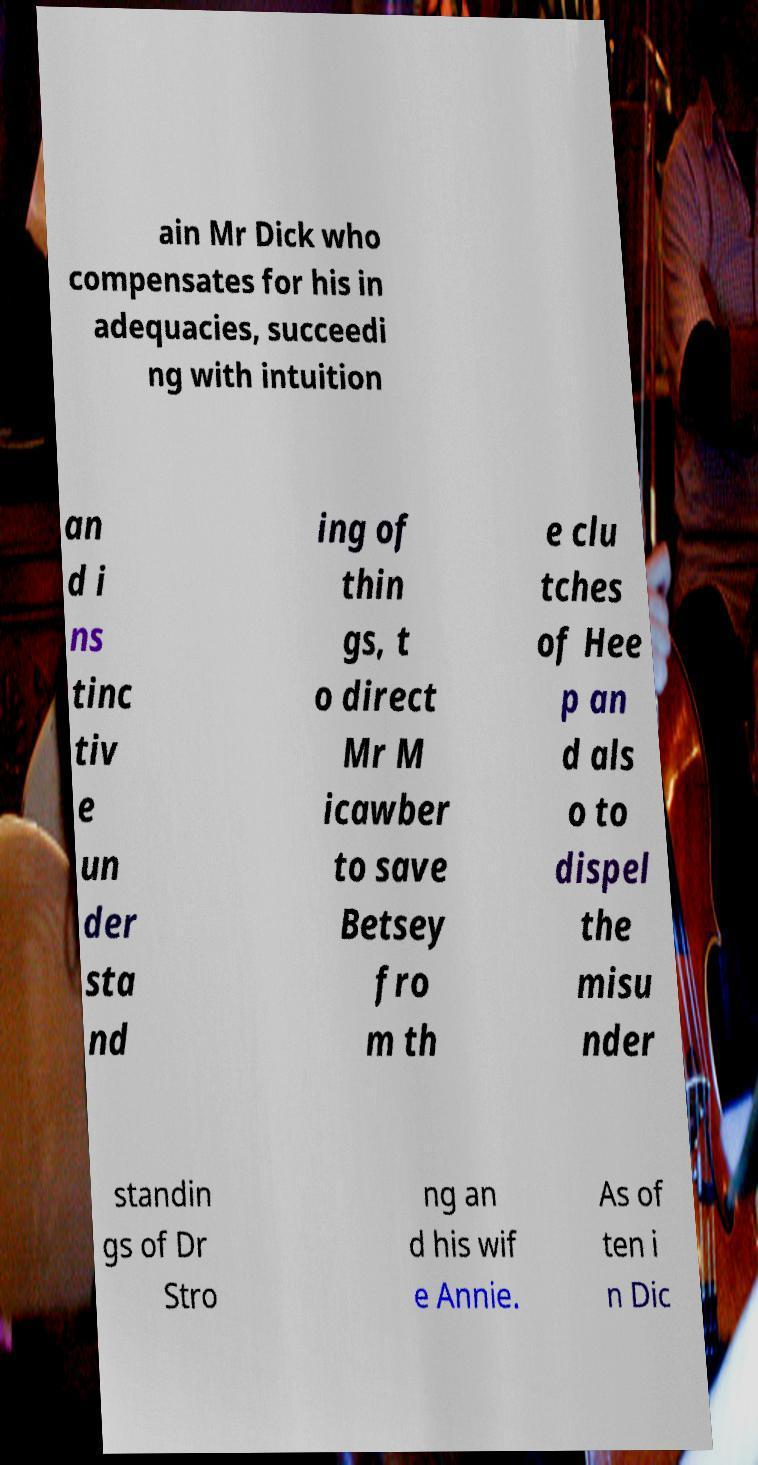Can you accurately transcribe the text from the provided image for me? ain Mr Dick who compensates for his in adequacies, succeedi ng with intuition an d i ns tinc tiv e un der sta nd ing of thin gs, t o direct Mr M icawber to save Betsey fro m th e clu tches of Hee p an d als o to dispel the misu nder standin gs of Dr Stro ng an d his wif e Annie. As of ten i n Dic 